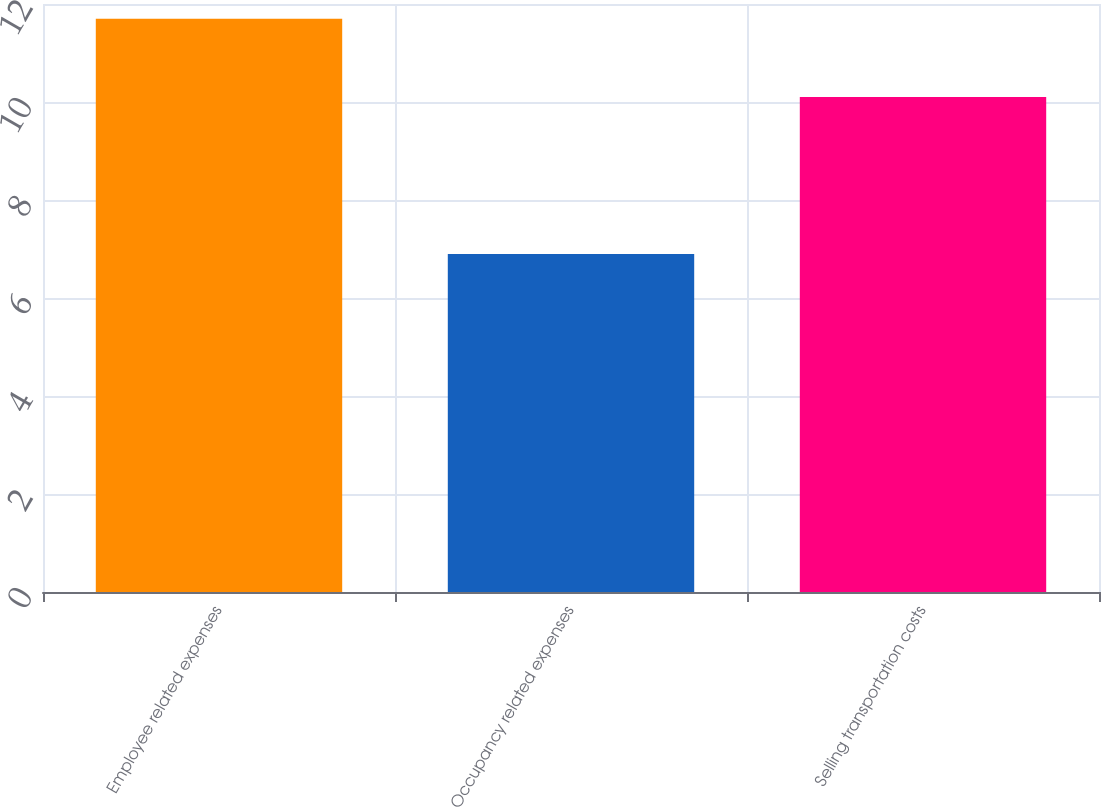Convert chart to OTSL. <chart><loc_0><loc_0><loc_500><loc_500><bar_chart><fcel>Employee related expenses<fcel>Occupancy related expenses<fcel>Selling transportation costs<nl><fcel>11.7<fcel>6.9<fcel>10.1<nl></chart> 